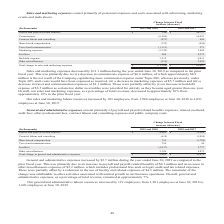According to Opentext Corporation's financial document, What does Sales and marketing expenses consist primarily of? personnel expenses and costs associated with advertising, marketing events and trade shows. The document states: "Sales and marketing expenses consist primarily of personnel expenses and costs associated with advertising, marketing events and trade shows...." Also, How many employees are there at June 30, 2019? According to the financial document, 2,051. The relevant text states: "ployees, from 1,948 employees at June 30, 2018 to 2,051 employees at June 30, 2019...." Also, What is the Total decrease in sales and marketing expenses from 2018 to 2019? According to the financial document, 11,106 (in thousands). The relevant text states: "Total change in sales and marketing expenses $ (11,106) $ 84,687..." Also, can you calculate: What is the Total change in sales and marketing expenses from fiscal year 2017 to 2019? Based on the calculation: 84,687-11,106, the result is 73581 (in thousands). This is based on the information: "Total change in sales and marketing expenses $ (11,106) $ 84,687 ange in sales and marketing expenses $ (11,106) $ 84,687..." The key data points involved are: 11,106, 84,687. Also, can you calculate: What is the average annual Total change in sales and marketing expenses?  To answer this question, I need to perform calculations using the financial data. The calculation is: (84,687-11,106)/2, which equals 36790.5 (in thousands). This is based on the information: "Total change in sales and marketing expenses $ (11,106) $ 84,687 ange in sales and marketing expenses $ (11,106) $ 84,687..." The key data points involved are: 11,106, 84,687. Also, can you calculate: What is the change in Marketing expenses from 2017 to 2019? Based on the calculation: 3,880-5,742, the result is -1862 (in thousands). This is based on the information: "Marketing expenses (5,742) 3,880 Marketing expenses (5,742) 3,880..." The key data points involved are: 3,880, 5,742. 